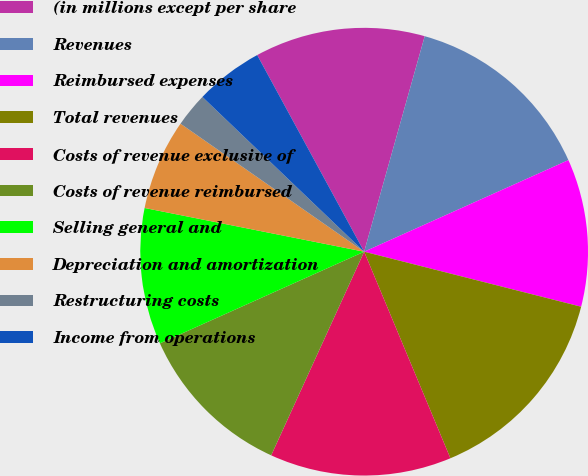Convert chart to OTSL. <chart><loc_0><loc_0><loc_500><loc_500><pie_chart><fcel>(in millions except per share<fcel>Revenues<fcel>Reimbursed expenses<fcel>Total revenues<fcel>Costs of revenue exclusive of<fcel>Costs of revenue reimbursed<fcel>Selling general and<fcel>Depreciation and amortization<fcel>Restructuring costs<fcel>Income from operations<nl><fcel>12.29%<fcel>13.93%<fcel>10.66%<fcel>14.75%<fcel>13.11%<fcel>11.47%<fcel>9.84%<fcel>6.56%<fcel>2.46%<fcel>4.92%<nl></chart> 